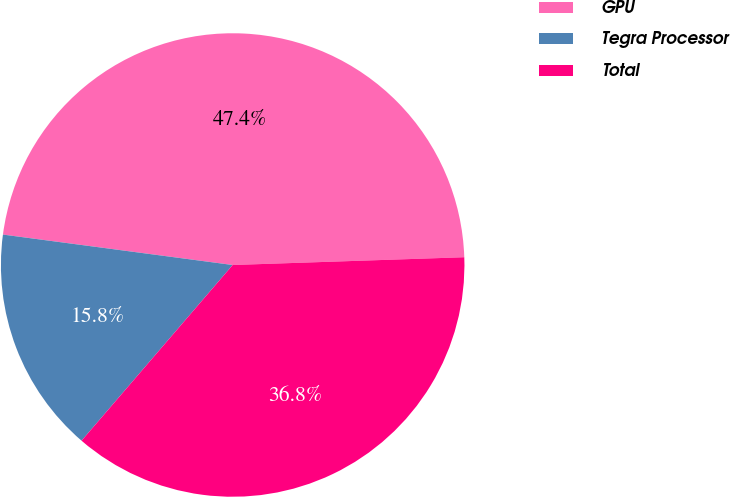<chart> <loc_0><loc_0><loc_500><loc_500><pie_chart><fcel>GPU<fcel>Tegra Processor<fcel>Total<nl><fcel>47.37%<fcel>15.79%<fcel>36.84%<nl></chart> 